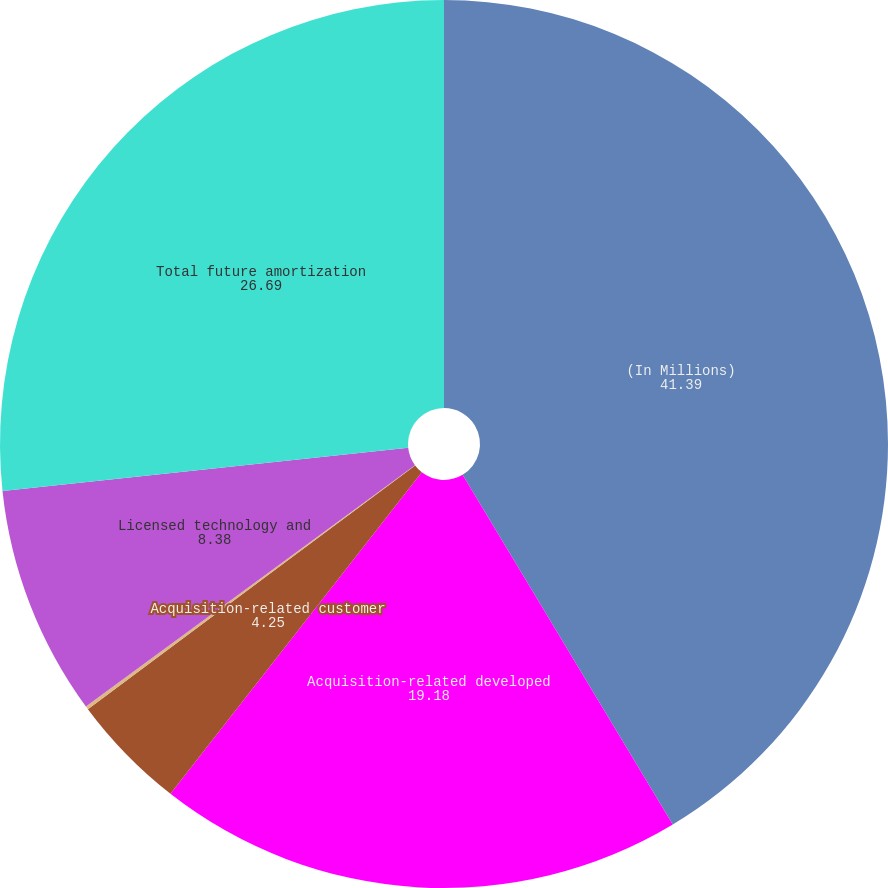<chart> <loc_0><loc_0><loc_500><loc_500><pie_chart><fcel>(In Millions)<fcel>Acquisition-related developed<fcel>Acquisition-related customer<fcel>Acquisition-related brands<fcel>Licensed technology and<fcel>Total future amortization<nl><fcel>41.39%<fcel>19.18%<fcel>4.25%<fcel>0.12%<fcel>8.38%<fcel>26.69%<nl></chart> 